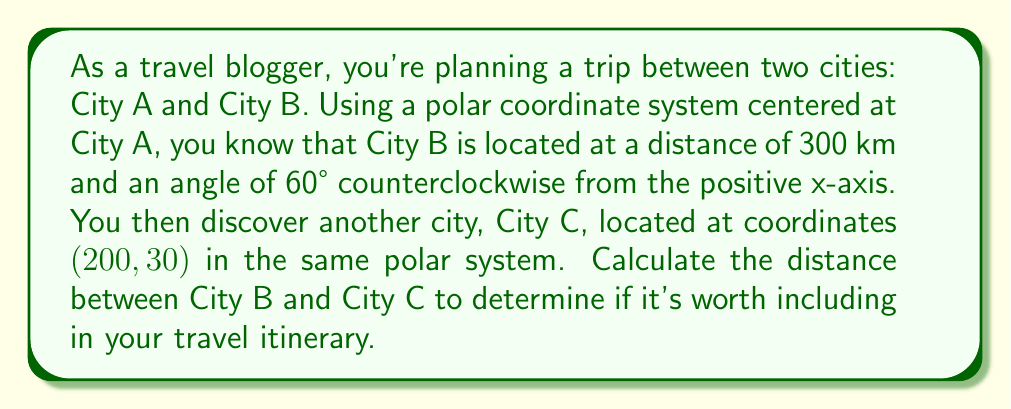Can you solve this math problem? To solve this problem, we'll use the law of cosines for polar coordinates. Let's break it down step by step:

1) First, let's define our known values:
   - City B: $r_1 = 300$ km, $\theta_1 = 60°$
   - City C: $r_2 = 200$ km, $\theta_2 = 30°$

2) The formula for the distance $d$ between two points $(r_1, \theta_1)$ and $(r_2, \theta_2)$ in polar coordinates is:

   $$d = \sqrt{r_1^2 + r_2^2 - 2r_1r_2 \cos(\theta_1 - \theta_2)}$$

3) Let's substitute our values:
   $$d = \sqrt{300^2 + 200^2 - 2(300)(200) \cos(60° - 30°)}$$

4) Simplify inside the cosine:
   $$d = \sqrt{300^2 + 200^2 - 2(300)(200) \cos(30°)}$$

5) Calculate the values:
   $$d = \sqrt{90,000 + 40,000 - 120,000 \cos(30°)}$$

6) We know that $\cos(30°) = \frac{\sqrt{3}}{2}$, so:
   $$d = \sqrt{90,000 + 40,000 - 120,000 (\frac{\sqrt{3}}{2})}$$

7) Simplify:
   $$d = \sqrt{130,000 - 60,000\sqrt{3}}$$

8) Calculate the final value:
   $$d \approx 158.11 \text{ km}$$

[asy]
import geometry;

size(200);
pair O=(0,0);
pair A=polar(300,60*pi/180);
pair B=polar(200,30*pi/180);
draw(O--A,Arrow);
draw(O--B,Arrow);
draw(A--B,dashed);
label("A (0,0)",O,SW);
label("B (300,60°)",A,NE);
label("C (200,30°)",B,E);
label("158.11 km",((A+B)/2),SE);
draw(arc(O,50,0,60),Arrow);
label("60°",polar(60,30*pi/180),N);
draw(arc(O,40,0,30),Arrow);
label("30°",polar(40,15*pi/180),N);
[/asy]
Answer: The distance between City B and City C is approximately 158.11 km. 